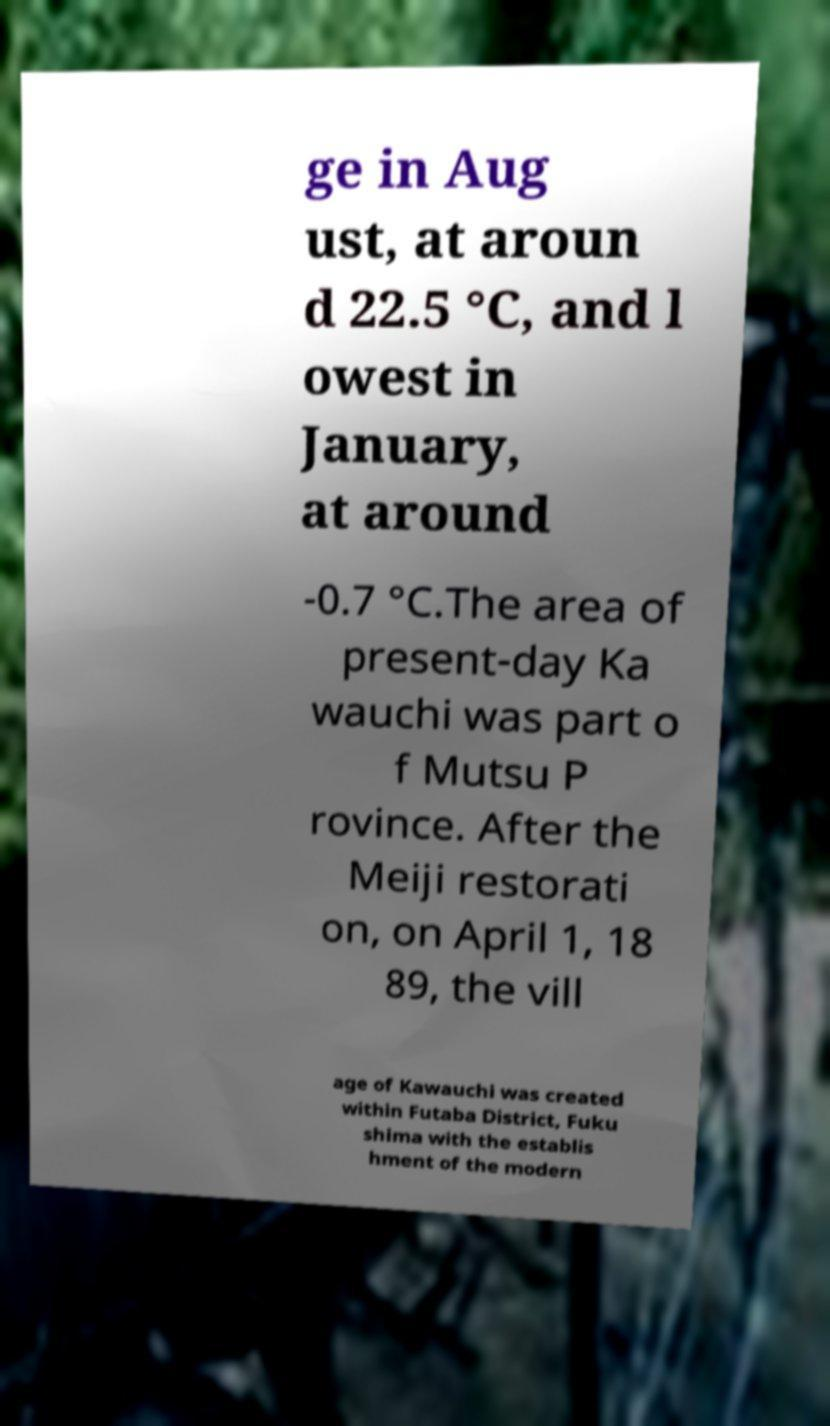Please identify and transcribe the text found in this image. ge in Aug ust, at aroun d 22.5 °C, and l owest in January, at around -0.7 °C.The area of present-day Ka wauchi was part o f Mutsu P rovince. After the Meiji restorati on, on April 1, 18 89, the vill age of Kawauchi was created within Futaba District, Fuku shima with the establis hment of the modern 